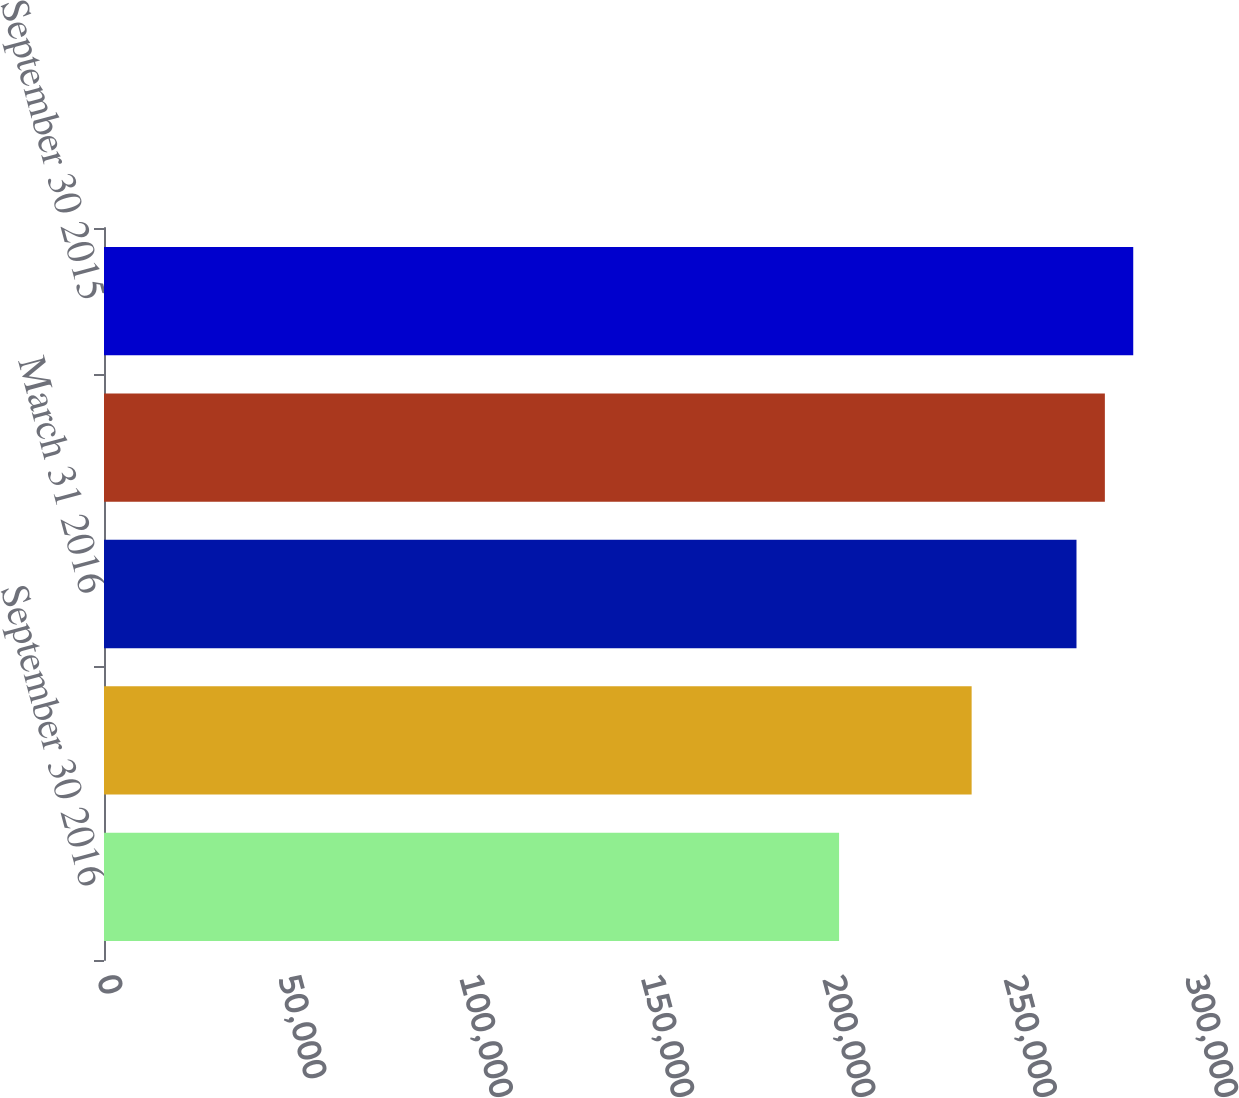Convert chart to OTSL. <chart><loc_0><loc_0><loc_500><loc_500><bar_chart><fcel>September 30 2016<fcel>June 30 2016<fcel>March 31 2016<fcel>December 31 2015<fcel>September 30 2015<nl><fcel>202687<fcel>239237<fcel>268150<fcel>275975<fcel>283799<nl></chart> 